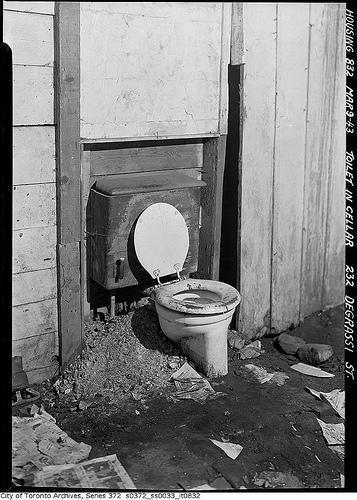How many toilets are there?
Give a very brief answer. 1. 